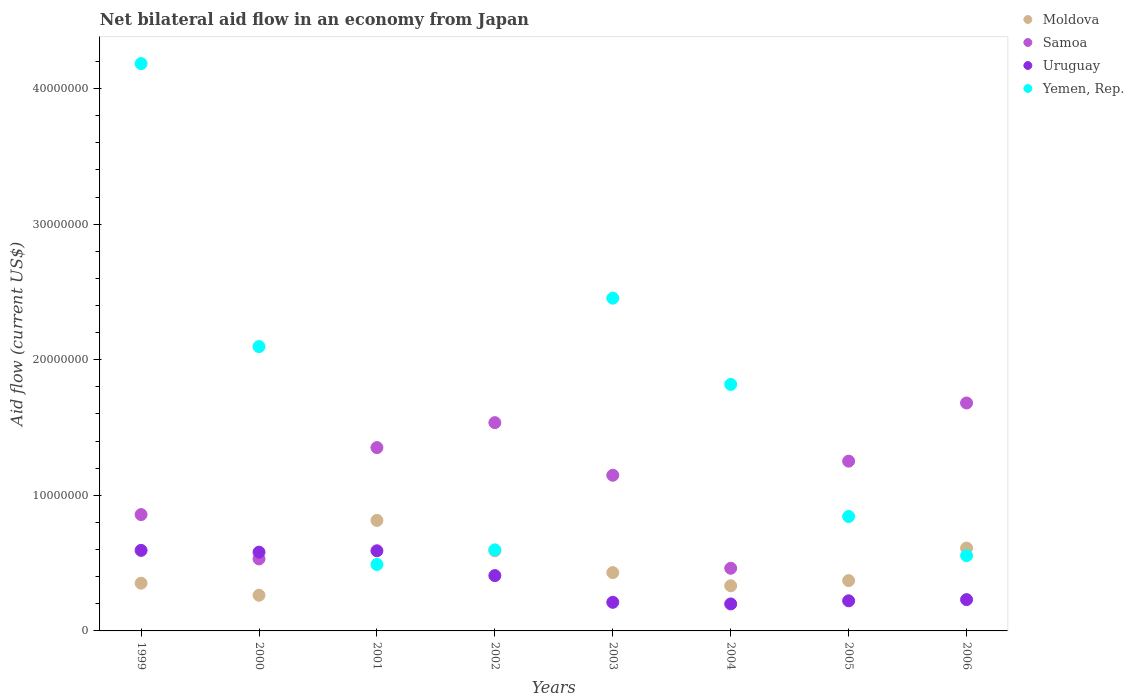What is the net bilateral aid flow in Moldova in 2006?
Your answer should be compact. 6.11e+06. Across all years, what is the maximum net bilateral aid flow in Moldova?
Provide a short and direct response. 8.15e+06. Across all years, what is the minimum net bilateral aid flow in Uruguay?
Provide a succinct answer. 1.99e+06. In which year was the net bilateral aid flow in Yemen, Rep. minimum?
Your answer should be very brief. 2001. What is the total net bilateral aid flow in Uruguay in the graph?
Give a very brief answer. 3.04e+07. What is the difference between the net bilateral aid flow in Samoa in 2001 and that in 2003?
Your answer should be very brief. 2.04e+06. What is the difference between the net bilateral aid flow in Uruguay in 2000 and the net bilateral aid flow in Yemen, Rep. in 2001?
Offer a terse response. 9.10e+05. What is the average net bilateral aid flow in Uruguay per year?
Make the answer very short. 3.80e+06. In the year 1999, what is the difference between the net bilateral aid flow in Moldova and net bilateral aid flow in Yemen, Rep.?
Your response must be concise. -3.83e+07. In how many years, is the net bilateral aid flow in Yemen, Rep. greater than 20000000 US$?
Provide a succinct answer. 3. What is the ratio of the net bilateral aid flow in Yemen, Rep. in 2000 to that in 2004?
Provide a succinct answer. 1.15. Is the net bilateral aid flow in Yemen, Rep. in 2005 less than that in 2006?
Ensure brevity in your answer.  No. What is the difference between the highest and the lowest net bilateral aid flow in Moldova?
Ensure brevity in your answer.  5.52e+06. Is the sum of the net bilateral aid flow in Samoa in 1999 and 2000 greater than the maximum net bilateral aid flow in Yemen, Rep. across all years?
Your answer should be compact. No. Is the net bilateral aid flow in Samoa strictly less than the net bilateral aid flow in Moldova over the years?
Give a very brief answer. No. How many dotlines are there?
Your response must be concise. 4. How many years are there in the graph?
Your response must be concise. 8. Are the values on the major ticks of Y-axis written in scientific E-notation?
Give a very brief answer. No. Does the graph contain any zero values?
Your response must be concise. No. Does the graph contain grids?
Provide a succinct answer. No. Where does the legend appear in the graph?
Offer a very short reply. Top right. How many legend labels are there?
Your response must be concise. 4. What is the title of the graph?
Provide a succinct answer. Net bilateral aid flow in an economy from Japan. What is the Aid flow (current US$) in Moldova in 1999?
Your response must be concise. 3.52e+06. What is the Aid flow (current US$) in Samoa in 1999?
Give a very brief answer. 8.58e+06. What is the Aid flow (current US$) in Uruguay in 1999?
Your answer should be compact. 5.94e+06. What is the Aid flow (current US$) in Yemen, Rep. in 1999?
Offer a very short reply. 4.18e+07. What is the Aid flow (current US$) of Moldova in 2000?
Make the answer very short. 2.63e+06. What is the Aid flow (current US$) of Samoa in 2000?
Your response must be concise. 5.31e+06. What is the Aid flow (current US$) in Uruguay in 2000?
Your answer should be compact. 5.81e+06. What is the Aid flow (current US$) of Yemen, Rep. in 2000?
Your answer should be very brief. 2.10e+07. What is the Aid flow (current US$) of Moldova in 2001?
Your answer should be very brief. 8.15e+06. What is the Aid flow (current US$) of Samoa in 2001?
Your answer should be very brief. 1.35e+07. What is the Aid flow (current US$) in Uruguay in 2001?
Your answer should be compact. 5.91e+06. What is the Aid flow (current US$) in Yemen, Rep. in 2001?
Provide a short and direct response. 4.90e+06. What is the Aid flow (current US$) in Moldova in 2002?
Make the answer very short. 5.91e+06. What is the Aid flow (current US$) in Samoa in 2002?
Make the answer very short. 1.54e+07. What is the Aid flow (current US$) of Uruguay in 2002?
Your answer should be compact. 4.08e+06. What is the Aid flow (current US$) of Yemen, Rep. in 2002?
Your answer should be very brief. 5.98e+06. What is the Aid flow (current US$) in Moldova in 2003?
Your answer should be compact. 4.30e+06. What is the Aid flow (current US$) of Samoa in 2003?
Your response must be concise. 1.15e+07. What is the Aid flow (current US$) in Uruguay in 2003?
Your answer should be compact. 2.11e+06. What is the Aid flow (current US$) of Yemen, Rep. in 2003?
Your answer should be very brief. 2.45e+07. What is the Aid flow (current US$) of Moldova in 2004?
Your answer should be very brief. 3.33e+06. What is the Aid flow (current US$) of Samoa in 2004?
Your answer should be compact. 4.62e+06. What is the Aid flow (current US$) in Uruguay in 2004?
Your answer should be very brief. 1.99e+06. What is the Aid flow (current US$) of Yemen, Rep. in 2004?
Your response must be concise. 1.82e+07. What is the Aid flow (current US$) in Moldova in 2005?
Keep it short and to the point. 3.71e+06. What is the Aid flow (current US$) of Samoa in 2005?
Provide a succinct answer. 1.25e+07. What is the Aid flow (current US$) of Uruguay in 2005?
Ensure brevity in your answer.  2.22e+06. What is the Aid flow (current US$) of Yemen, Rep. in 2005?
Give a very brief answer. 8.44e+06. What is the Aid flow (current US$) of Moldova in 2006?
Offer a terse response. 6.11e+06. What is the Aid flow (current US$) of Samoa in 2006?
Provide a short and direct response. 1.68e+07. What is the Aid flow (current US$) of Uruguay in 2006?
Ensure brevity in your answer.  2.31e+06. What is the Aid flow (current US$) of Yemen, Rep. in 2006?
Offer a very short reply. 5.55e+06. Across all years, what is the maximum Aid flow (current US$) in Moldova?
Your answer should be very brief. 8.15e+06. Across all years, what is the maximum Aid flow (current US$) in Samoa?
Ensure brevity in your answer.  1.68e+07. Across all years, what is the maximum Aid flow (current US$) of Uruguay?
Offer a very short reply. 5.94e+06. Across all years, what is the maximum Aid flow (current US$) in Yemen, Rep.?
Ensure brevity in your answer.  4.18e+07. Across all years, what is the minimum Aid flow (current US$) in Moldova?
Provide a succinct answer. 2.63e+06. Across all years, what is the minimum Aid flow (current US$) in Samoa?
Provide a succinct answer. 4.62e+06. Across all years, what is the minimum Aid flow (current US$) of Uruguay?
Your answer should be very brief. 1.99e+06. Across all years, what is the minimum Aid flow (current US$) of Yemen, Rep.?
Provide a succinct answer. 4.90e+06. What is the total Aid flow (current US$) in Moldova in the graph?
Your response must be concise. 3.77e+07. What is the total Aid flow (current US$) of Samoa in the graph?
Give a very brief answer. 8.82e+07. What is the total Aid flow (current US$) of Uruguay in the graph?
Your answer should be very brief. 3.04e+07. What is the total Aid flow (current US$) of Yemen, Rep. in the graph?
Offer a terse response. 1.30e+08. What is the difference between the Aid flow (current US$) of Moldova in 1999 and that in 2000?
Your response must be concise. 8.90e+05. What is the difference between the Aid flow (current US$) in Samoa in 1999 and that in 2000?
Your answer should be very brief. 3.27e+06. What is the difference between the Aid flow (current US$) of Yemen, Rep. in 1999 and that in 2000?
Give a very brief answer. 2.09e+07. What is the difference between the Aid flow (current US$) in Moldova in 1999 and that in 2001?
Make the answer very short. -4.63e+06. What is the difference between the Aid flow (current US$) of Samoa in 1999 and that in 2001?
Your response must be concise. -4.94e+06. What is the difference between the Aid flow (current US$) in Yemen, Rep. in 1999 and that in 2001?
Provide a short and direct response. 3.69e+07. What is the difference between the Aid flow (current US$) in Moldova in 1999 and that in 2002?
Provide a succinct answer. -2.39e+06. What is the difference between the Aid flow (current US$) in Samoa in 1999 and that in 2002?
Keep it short and to the point. -6.78e+06. What is the difference between the Aid flow (current US$) of Uruguay in 1999 and that in 2002?
Ensure brevity in your answer.  1.86e+06. What is the difference between the Aid flow (current US$) in Yemen, Rep. in 1999 and that in 2002?
Your answer should be compact. 3.59e+07. What is the difference between the Aid flow (current US$) in Moldova in 1999 and that in 2003?
Make the answer very short. -7.80e+05. What is the difference between the Aid flow (current US$) in Samoa in 1999 and that in 2003?
Your response must be concise. -2.90e+06. What is the difference between the Aid flow (current US$) of Uruguay in 1999 and that in 2003?
Ensure brevity in your answer.  3.83e+06. What is the difference between the Aid flow (current US$) of Yemen, Rep. in 1999 and that in 2003?
Your response must be concise. 1.73e+07. What is the difference between the Aid flow (current US$) in Samoa in 1999 and that in 2004?
Keep it short and to the point. 3.96e+06. What is the difference between the Aid flow (current US$) in Uruguay in 1999 and that in 2004?
Your response must be concise. 3.95e+06. What is the difference between the Aid flow (current US$) of Yemen, Rep. in 1999 and that in 2004?
Provide a short and direct response. 2.37e+07. What is the difference between the Aid flow (current US$) in Moldova in 1999 and that in 2005?
Your answer should be compact. -1.90e+05. What is the difference between the Aid flow (current US$) of Samoa in 1999 and that in 2005?
Give a very brief answer. -3.94e+06. What is the difference between the Aid flow (current US$) of Uruguay in 1999 and that in 2005?
Your answer should be very brief. 3.72e+06. What is the difference between the Aid flow (current US$) in Yemen, Rep. in 1999 and that in 2005?
Ensure brevity in your answer.  3.34e+07. What is the difference between the Aid flow (current US$) in Moldova in 1999 and that in 2006?
Offer a terse response. -2.59e+06. What is the difference between the Aid flow (current US$) of Samoa in 1999 and that in 2006?
Offer a very short reply. -8.23e+06. What is the difference between the Aid flow (current US$) of Uruguay in 1999 and that in 2006?
Your response must be concise. 3.63e+06. What is the difference between the Aid flow (current US$) of Yemen, Rep. in 1999 and that in 2006?
Provide a succinct answer. 3.63e+07. What is the difference between the Aid flow (current US$) in Moldova in 2000 and that in 2001?
Your answer should be very brief. -5.52e+06. What is the difference between the Aid flow (current US$) in Samoa in 2000 and that in 2001?
Offer a very short reply. -8.21e+06. What is the difference between the Aid flow (current US$) of Yemen, Rep. in 2000 and that in 2001?
Provide a succinct answer. 1.61e+07. What is the difference between the Aid flow (current US$) in Moldova in 2000 and that in 2002?
Provide a succinct answer. -3.28e+06. What is the difference between the Aid flow (current US$) in Samoa in 2000 and that in 2002?
Your answer should be compact. -1.00e+07. What is the difference between the Aid flow (current US$) of Uruguay in 2000 and that in 2002?
Provide a succinct answer. 1.73e+06. What is the difference between the Aid flow (current US$) in Yemen, Rep. in 2000 and that in 2002?
Offer a terse response. 1.50e+07. What is the difference between the Aid flow (current US$) of Moldova in 2000 and that in 2003?
Provide a short and direct response. -1.67e+06. What is the difference between the Aid flow (current US$) in Samoa in 2000 and that in 2003?
Make the answer very short. -6.17e+06. What is the difference between the Aid flow (current US$) of Uruguay in 2000 and that in 2003?
Make the answer very short. 3.70e+06. What is the difference between the Aid flow (current US$) in Yemen, Rep. in 2000 and that in 2003?
Your answer should be compact. -3.57e+06. What is the difference between the Aid flow (current US$) of Moldova in 2000 and that in 2004?
Provide a succinct answer. -7.00e+05. What is the difference between the Aid flow (current US$) of Samoa in 2000 and that in 2004?
Ensure brevity in your answer.  6.90e+05. What is the difference between the Aid flow (current US$) in Uruguay in 2000 and that in 2004?
Ensure brevity in your answer.  3.82e+06. What is the difference between the Aid flow (current US$) in Yemen, Rep. in 2000 and that in 2004?
Give a very brief answer. 2.79e+06. What is the difference between the Aid flow (current US$) of Moldova in 2000 and that in 2005?
Keep it short and to the point. -1.08e+06. What is the difference between the Aid flow (current US$) in Samoa in 2000 and that in 2005?
Your response must be concise. -7.21e+06. What is the difference between the Aid flow (current US$) in Uruguay in 2000 and that in 2005?
Make the answer very short. 3.59e+06. What is the difference between the Aid flow (current US$) in Yemen, Rep. in 2000 and that in 2005?
Give a very brief answer. 1.25e+07. What is the difference between the Aid flow (current US$) in Moldova in 2000 and that in 2006?
Provide a short and direct response. -3.48e+06. What is the difference between the Aid flow (current US$) in Samoa in 2000 and that in 2006?
Provide a succinct answer. -1.15e+07. What is the difference between the Aid flow (current US$) of Uruguay in 2000 and that in 2006?
Offer a very short reply. 3.50e+06. What is the difference between the Aid flow (current US$) in Yemen, Rep. in 2000 and that in 2006?
Make the answer very short. 1.54e+07. What is the difference between the Aid flow (current US$) of Moldova in 2001 and that in 2002?
Provide a short and direct response. 2.24e+06. What is the difference between the Aid flow (current US$) of Samoa in 2001 and that in 2002?
Offer a very short reply. -1.84e+06. What is the difference between the Aid flow (current US$) in Uruguay in 2001 and that in 2002?
Give a very brief answer. 1.83e+06. What is the difference between the Aid flow (current US$) of Yemen, Rep. in 2001 and that in 2002?
Give a very brief answer. -1.08e+06. What is the difference between the Aid flow (current US$) of Moldova in 2001 and that in 2003?
Provide a succinct answer. 3.85e+06. What is the difference between the Aid flow (current US$) in Samoa in 2001 and that in 2003?
Ensure brevity in your answer.  2.04e+06. What is the difference between the Aid flow (current US$) in Uruguay in 2001 and that in 2003?
Provide a short and direct response. 3.80e+06. What is the difference between the Aid flow (current US$) in Yemen, Rep. in 2001 and that in 2003?
Make the answer very short. -1.96e+07. What is the difference between the Aid flow (current US$) of Moldova in 2001 and that in 2004?
Your response must be concise. 4.82e+06. What is the difference between the Aid flow (current US$) of Samoa in 2001 and that in 2004?
Give a very brief answer. 8.90e+06. What is the difference between the Aid flow (current US$) in Uruguay in 2001 and that in 2004?
Ensure brevity in your answer.  3.92e+06. What is the difference between the Aid flow (current US$) in Yemen, Rep. in 2001 and that in 2004?
Keep it short and to the point. -1.33e+07. What is the difference between the Aid flow (current US$) in Moldova in 2001 and that in 2005?
Your answer should be compact. 4.44e+06. What is the difference between the Aid flow (current US$) in Uruguay in 2001 and that in 2005?
Keep it short and to the point. 3.69e+06. What is the difference between the Aid flow (current US$) of Yemen, Rep. in 2001 and that in 2005?
Ensure brevity in your answer.  -3.54e+06. What is the difference between the Aid flow (current US$) of Moldova in 2001 and that in 2006?
Make the answer very short. 2.04e+06. What is the difference between the Aid flow (current US$) of Samoa in 2001 and that in 2006?
Keep it short and to the point. -3.29e+06. What is the difference between the Aid flow (current US$) of Uruguay in 2001 and that in 2006?
Offer a terse response. 3.60e+06. What is the difference between the Aid flow (current US$) in Yemen, Rep. in 2001 and that in 2006?
Give a very brief answer. -6.50e+05. What is the difference between the Aid flow (current US$) of Moldova in 2002 and that in 2003?
Offer a terse response. 1.61e+06. What is the difference between the Aid flow (current US$) in Samoa in 2002 and that in 2003?
Give a very brief answer. 3.88e+06. What is the difference between the Aid flow (current US$) in Uruguay in 2002 and that in 2003?
Ensure brevity in your answer.  1.97e+06. What is the difference between the Aid flow (current US$) of Yemen, Rep. in 2002 and that in 2003?
Ensure brevity in your answer.  -1.86e+07. What is the difference between the Aid flow (current US$) of Moldova in 2002 and that in 2004?
Give a very brief answer. 2.58e+06. What is the difference between the Aid flow (current US$) in Samoa in 2002 and that in 2004?
Your answer should be very brief. 1.07e+07. What is the difference between the Aid flow (current US$) of Uruguay in 2002 and that in 2004?
Provide a succinct answer. 2.09e+06. What is the difference between the Aid flow (current US$) in Yemen, Rep. in 2002 and that in 2004?
Ensure brevity in your answer.  -1.22e+07. What is the difference between the Aid flow (current US$) of Moldova in 2002 and that in 2005?
Provide a succinct answer. 2.20e+06. What is the difference between the Aid flow (current US$) of Samoa in 2002 and that in 2005?
Provide a short and direct response. 2.84e+06. What is the difference between the Aid flow (current US$) in Uruguay in 2002 and that in 2005?
Your answer should be very brief. 1.86e+06. What is the difference between the Aid flow (current US$) of Yemen, Rep. in 2002 and that in 2005?
Give a very brief answer. -2.46e+06. What is the difference between the Aid flow (current US$) of Moldova in 2002 and that in 2006?
Provide a short and direct response. -2.00e+05. What is the difference between the Aid flow (current US$) of Samoa in 2002 and that in 2006?
Your answer should be compact. -1.45e+06. What is the difference between the Aid flow (current US$) in Uruguay in 2002 and that in 2006?
Provide a succinct answer. 1.77e+06. What is the difference between the Aid flow (current US$) in Moldova in 2003 and that in 2004?
Ensure brevity in your answer.  9.70e+05. What is the difference between the Aid flow (current US$) of Samoa in 2003 and that in 2004?
Offer a very short reply. 6.86e+06. What is the difference between the Aid flow (current US$) of Uruguay in 2003 and that in 2004?
Offer a very short reply. 1.20e+05. What is the difference between the Aid flow (current US$) in Yemen, Rep. in 2003 and that in 2004?
Provide a succinct answer. 6.36e+06. What is the difference between the Aid flow (current US$) of Moldova in 2003 and that in 2005?
Ensure brevity in your answer.  5.90e+05. What is the difference between the Aid flow (current US$) in Samoa in 2003 and that in 2005?
Ensure brevity in your answer.  -1.04e+06. What is the difference between the Aid flow (current US$) of Yemen, Rep. in 2003 and that in 2005?
Your answer should be compact. 1.61e+07. What is the difference between the Aid flow (current US$) in Moldova in 2003 and that in 2006?
Keep it short and to the point. -1.81e+06. What is the difference between the Aid flow (current US$) of Samoa in 2003 and that in 2006?
Give a very brief answer. -5.33e+06. What is the difference between the Aid flow (current US$) in Uruguay in 2003 and that in 2006?
Your response must be concise. -2.00e+05. What is the difference between the Aid flow (current US$) in Yemen, Rep. in 2003 and that in 2006?
Offer a terse response. 1.90e+07. What is the difference between the Aid flow (current US$) of Moldova in 2004 and that in 2005?
Your answer should be very brief. -3.80e+05. What is the difference between the Aid flow (current US$) of Samoa in 2004 and that in 2005?
Provide a short and direct response. -7.90e+06. What is the difference between the Aid flow (current US$) of Yemen, Rep. in 2004 and that in 2005?
Make the answer very short. 9.74e+06. What is the difference between the Aid flow (current US$) of Moldova in 2004 and that in 2006?
Provide a short and direct response. -2.78e+06. What is the difference between the Aid flow (current US$) in Samoa in 2004 and that in 2006?
Your answer should be compact. -1.22e+07. What is the difference between the Aid flow (current US$) in Uruguay in 2004 and that in 2006?
Your answer should be compact. -3.20e+05. What is the difference between the Aid flow (current US$) in Yemen, Rep. in 2004 and that in 2006?
Give a very brief answer. 1.26e+07. What is the difference between the Aid flow (current US$) in Moldova in 2005 and that in 2006?
Make the answer very short. -2.40e+06. What is the difference between the Aid flow (current US$) in Samoa in 2005 and that in 2006?
Provide a short and direct response. -4.29e+06. What is the difference between the Aid flow (current US$) of Yemen, Rep. in 2005 and that in 2006?
Offer a very short reply. 2.89e+06. What is the difference between the Aid flow (current US$) in Moldova in 1999 and the Aid flow (current US$) in Samoa in 2000?
Give a very brief answer. -1.79e+06. What is the difference between the Aid flow (current US$) of Moldova in 1999 and the Aid flow (current US$) of Uruguay in 2000?
Provide a short and direct response. -2.29e+06. What is the difference between the Aid flow (current US$) of Moldova in 1999 and the Aid flow (current US$) of Yemen, Rep. in 2000?
Your response must be concise. -1.74e+07. What is the difference between the Aid flow (current US$) of Samoa in 1999 and the Aid flow (current US$) of Uruguay in 2000?
Offer a very short reply. 2.77e+06. What is the difference between the Aid flow (current US$) in Samoa in 1999 and the Aid flow (current US$) in Yemen, Rep. in 2000?
Offer a terse response. -1.24e+07. What is the difference between the Aid flow (current US$) of Uruguay in 1999 and the Aid flow (current US$) of Yemen, Rep. in 2000?
Keep it short and to the point. -1.50e+07. What is the difference between the Aid flow (current US$) in Moldova in 1999 and the Aid flow (current US$) in Samoa in 2001?
Offer a very short reply. -1.00e+07. What is the difference between the Aid flow (current US$) in Moldova in 1999 and the Aid flow (current US$) in Uruguay in 2001?
Make the answer very short. -2.39e+06. What is the difference between the Aid flow (current US$) in Moldova in 1999 and the Aid flow (current US$) in Yemen, Rep. in 2001?
Ensure brevity in your answer.  -1.38e+06. What is the difference between the Aid flow (current US$) of Samoa in 1999 and the Aid flow (current US$) of Uruguay in 2001?
Offer a very short reply. 2.67e+06. What is the difference between the Aid flow (current US$) of Samoa in 1999 and the Aid flow (current US$) of Yemen, Rep. in 2001?
Your answer should be compact. 3.68e+06. What is the difference between the Aid flow (current US$) of Uruguay in 1999 and the Aid flow (current US$) of Yemen, Rep. in 2001?
Provide a short and direct response. 1.04e+06. What is the difference between the Aid flow (current US$) of Moldova in 1999 and the Aid flow (current US$) of Samoa in 2002?
Your answer should be very brief. -1.18e+07. What is the difference between the Aid flow (current US$) in Moldova in 1999 and the Aid flow (current US$) in Uruguay in 2002?
Offer a terse response. -5.60e+05. What is the difference between the Aid flow (current US$) in Moldova in 1999 and the Aid flow (current US$) in Yemen, Rep. in 2002?
Give a very brief answer. -2.46e+06. What is the difference between the Aid flow (current US$) of Samoa in 1999 and the Aid flow (current US$) of Uruguay in 2002?
Offer a terse response. 4.50e+06. What is the difference between the Aid flow (current US$) of Samoa in 1999 and the Aid flow (current US$) of Yemen, Rep. in 2002?
Make the answer very short. 2.60e+06. What is the difference between the Aid flow (current US$) of Uruguay in 1999 and the Aid flow (current US$) of Yemen, Rep. in 2002?
Your answer should be compact. -4.00e+04. What is the difference between the Aid flow (current US$) in Moldova in 1999 and the Aid flow (current US$) in Samoa in 2003?
Make the answer very short. -7.96e+06. What is the difference between the Aid flow (current US$) in Moldova in 1999 and the Aid flow (current US$) in Uruguay in 2003?
Offer a very short reply. 1.41e+06. What is the difference between the Aid flow (current US$) in Moldova in 1999 and the Aid flow (current US$) in Yemen, Rep. in 2003?
Keep it short and to the point. -2.10e+07. What is the difference between the Aid flow (current US$) of Samoa in 1999 and the Aid flow (current US$) of Uruguay in 2003?
Make the answer very short. 6.47e+06. What is the difference between the Aid flow (current US$) of Samoa in 1999 and the Aid flow (current US$) of Yemen, Rep. in 2003?
Keep it short and to the point. -1.60e+07. What is the difference between the Aid flow (current US$) in Uruguay in 1999 and the Aid flow (current US$) in Yemen, Rep. in 2003?
Give a very brief answer. -1.86e+07. What is the difference between the Aid flow (current US$) in Moldova in 1999 and the Aid flow (current US$) in Samoa in 2004?
Keep it short and to the point. -1.10e+06. What is the difference between the Aid flow (current US$) in Moldova in 1999 and the Aid flow (current US$) in Uruguay in 2004?
Provide a short and direct response. 1.53e+06. What is the difference between the Aid flow (current US$) in Moldova in 1999 and the Aid flow (current US$) in Yemen, Rep. in 2004?
Your answer should be very brief. -1.47e+07. What is the difference between the Aid flow (current US$) of Samoa in 1999 and the Aid flow (current US$) of Uruguay in 2004?
Keep it short and to the point. 6.59e+06. What is the difference between the Aid flow (current US$) of Samoa in 1999 and the Aid flow (current US$) of Yemen, Rep. in 2004?
Offer a terse response. -9.60e+06. What is the difference between the Aid flow (current US$) of Uruguay in 1999 and the Aid flow (current US$) of Yemen, Rep. in 2004?
Make the answer very short. -1.22e+07. What is the difference between the Aid flow (current US$) of Moldova in 1999 and the Aid flow (current US$) of Samoa in 2005?
Your answer should be very brief. -9.00e+06. What is the difference between the Aid flow (current US$) of Moldova in 1999 and the Aid flow (current US$) of Uruguay in 2005?
Make the answer very short. 1.30e+06. What is the difference between the Aid flow (current US$) in Moldova in 1999 and the Aid flow (current US$) in Yemen, Rep. in 2005?
Offer a terse response. -4.92e+06. What is the difference between the Aid flow (current US$) of Samoa in 1999 and the Aid flow (current US$) of Uruguay in 2005?
Ensure brevity in your answer.  6.36e+06. What is the difference between the Aid flow (current US$) in Uruguay in 1999 and the Aid flow (current US$) in Yemen, Rep. in 2005?
Offer a very short reply. -2.50e+06. What is the difference between the Aid flow (current US$) of Moldova in 1999 and the Aid flow (current US$) of Samoa in 2006?
Make the answer very short. -1.33e+07. What is the difference between the Aid flow (current US$) in Moldova in 1999 and the Aid flow (current US$) in Uruguay in 2006?
Your answer should be compact. 1.21e+06. What is the difference between the Aid flow (current US$) in Moldova in 1999 and the Aid flow (current US$) in Yemen, Rep. in 2006?
Offer a terse response. -2.03e+06. What is the difference between the Aid flow (current US$) in Samoa in 1999 and the Aid flow (current US$) in Uruguay in 2006?
Give a very brief answer. 6.27e+06. What is the difference between the Aid flow (current US$) of Samoa in 1999 and the Aid flow (current US$) of Yemen, Rep. in 2006?
Make the answer very short. 3.03e+06. What is the difference between the Aid flow (current US$) in Uruguay in 1999 and the Aid flow (current US$) in Yemen, Rep. in 2006?
Keep it short and to the point. 3.90e+05. What is the difference between the Aid flow (current US$) in Moldova in 2000 and the Aid flow (current US$) in Samoa in 2001?
Your response must be concise. -1.09e+07. What is the difference between the Aid flow (current US$) in Moldova in 2000 and the Aid flow (current US$) in Uruguay in 2001?
Offer a terse response. -3.28e+06. What is the difference between the Aid flow (current US$) of Moldova in 2000 and the Aid flow (current US$) of Yemen, Rep. in 2001?
Give a very brief answer. -2.27e+06. What is the difference between the Aid flow (current US$) in Samoa in 2000 and the Aid flow (current US$) in Uruguay in 2001?
Your answer should be very brief. -6.00e+05. What is the difference between the Aid flow (current US$) in Uruguay in 2000 and the Aid flow (current US$) in Yemen, Rep. in 2001?
Your answer should be very brief. 9.10e+05. What is the difference between the Aid flow (current US$) in Moldova in 2000 and the Aid flow (current US$) in Samoa in 2002?
Ensure brevity in your answer.  -1.27e+07. What is the difference between the Aid flow (current US$) of Moldova in 2000 and the Aid flow (current US$) of Uruguay in 2002?
Your response must be concise. -1.45e+06. What is the difference between the Aid flow (current US$) of Moldova in 2000 and the Aid flow (current US$) of Yemen, Rep. in 2002?
Offer a very short reply. -3.35e+06. What is the difference between the Aid flow (current US$) of Samoa in 2000 and the Aid flow (current US$) of Uruguay in 2002?
Provide a succinct answer. 1.23e+06. What is the difference between the Aid flow (current US$) of Samoa in 2000 and the Aid flow (current US$) of Yemen, Rep. in 2002?
Your answer should be compact. -6.70e+05. What is the difference between the Aid flow (current US$) of Moldova in 2000 and the Aid flow (current US$) of Samoa in 2003?
Give a very brief answer. -8.85e+06. What is the difference between the Aid flow (current US$) of Moldova in 2000 and the Aid flow (current US$) of Uruguay in 2003?
Offer a very short reply. 5.20e+05. What is the difference between the Aid flow (current US$) in Moldova in 2000 and the Aid flow (current US$) in Yemen, Rep. in 2003?
Make the answer very short. -2.19e+07. What is the difference between the Aid flow (current US$) of Samoa in 2000 and the Aid flow (current US$) of Uruguay in 2003?
Give a very brief answer. 3.20e+06. What is the difference between the Aid flow (current US$) of Samoa in 2000 and the Aid flow (current US$) of Yemen, Rep. in 2003?
Offer a very short reply. -1.92e+07. What is the difference between the Aid flow (current US$) in Uruguay in 2000 and the Aid flow (current US$) in Yemen, Rep. in 2003?
Give a very brief answer. -1.87e+07. What is the difference between the Aid flow (current US$) in Moldova in 2000 and the Aid flow (current US$) in Samoa in 2004?
Provide a succinct answer. -1.99e+06. What is the difference between the Aid flow (current US$) of Moldova in 2000 and the Aid flow (current US$) of Uruguay in 2004?
Offer a very short reply. 6.40e+05. What is the difference between the Aid flow (current US$) in Moldova in 2000 and the Aid flow (current US$) in Yemen, Rep. in 2004?
Keep it short and to the point. -1.56e+07. What is the difference between the Aid flow (current US$) in Samoa in 2000 and the Aid flow (current US$) in Uruguay in 2004?
Provide a short and direct response. 3.32e+06. What is the difference between the Aid flow (current US$) in Samoa in 2000 and the Aid flow (current US$) in Yemen, Rep. in 2004?
Give a very brief answer. -1.29e+07. What is the difference between the Aid flow (current US$) of Uruguay in 2000 and the Aid flow (current US$) of Yemen, Rep. in 2004?
Give a very brief answer. -1.24e+07. What is the difference between the Aid flow (current US$) of Moldova in 2000 and the Aid flow (current US$) of Samoa in 2005?
Your answer should be compact. -9.89e+06. What is the difference between the Aid flow (current US$) of Moldova in 2000 and the Aid flow (current US$) of Yemen, Rep. in 2005?
Your answer should be very brief. -5.81e+06. What is the difference between the Aid flow (current US$) in Samoa in 2000 and the Aid flow (current US$) in Uruguay in 2005?
Offer a terse response. 3.09e+06. What is the difference between the Aid flow (current US$) of Samoa in 2000 and the Aid flow (current US$) of Yemen, Rep. in 2005?
Give a very brief answer. -3.13e+06. What is the difference between the Aid flow (current US$) of Uruguay in 2000 and the Aid flow (current US$) of Yemen, Rep. in 2005?
Provide a short and direct response. -2.63e+06. What is the difference between the Aid flow (current US$) of Moldova in 2000 and the Aid flow (current US$) of Samoa in 2006?
Ensure brevity in your answer.  -1.42e+07. What is the difference between the Aid flow (current US$) of Moldova in 2000 and the Aid flow (current US$) of Uruguay in 2006?
Offer a terse response. 3.20e+05. What is the difference between the Aid flow (current US$) of Moldova in 2000 and the Aid flow (current US$) of Yemen, Rep. in 2006?
Give a very brief answer. -2.92e+06. What is the difference between the Aid flow (current US$) in Moldova in 2001 and the Aid flow (current US$) in Samoa in 2002?
Give a very brief answer. -7.21e+06. What is the difference between the Aid flow (current US$) in Moldova in 2001 and the Aid flow (current US$) in Uruguay in 2002?
Your response must be concise. 4.07e+06. What is the difference between the Aid flow (current US$) of Moldova in 2001 and the Aid flow (current US$) of Yemen, Rep. in 2002?
Ensure brevity in your answer.  2.17e+06. What is the difference between the Aid flow (current US$) in Samoa in 2001 and the Aid flow (current US$) in Uruguay in 2002?
Your answer should be compact. 9.44e+06. What is the difference between the Aid flow (current US$) in Samoa in 2001 and the Aid flow (current US$) in Yemen, Rep. in 2002?
Your response must be concise. 7.54e+06. What is the difference between the Aid flow (current US$) of Uruguay in 2001 and the Aid flow (current US$) of Yemen, Rep. in 2002?
Provide a succinct answer. -7.00e+04. What is the difference between the Aid flow (current US$) of Moldova in 2001 and the Aid flow (current US$) of Samoa in 2003?
Your response must be concise. -3.33e+06. What is the difference between the Aid flow (current US$) of Moldova in 2001 and the Aid flow (current US$) of Uruguay in 2003?
Your answer should be very brief. 6.04e+06. What is the difference between the Aid flow (current US$) of Moldova in 2001 and the Aid flow (current US$) of Yemen, Rep. in 2003?
Ensure brevity in your answer.  -1.64e+07. What is the difference between the Aid flow (current US$) of Samoa in 2001 and the Aid flow (current US$) of Uruguay in 2003?
Keep it short and to the point. 1.14e+07. What is the difference between the Aid flow (current US$) in Samoa in 2001 and the Aid flow (current US$) in Yemen, Rep. in 2003?
Offer a terse response. -1.10e+07. What is the difference between the Aid flow (current US$) in Uruguay in 2001 and the Aid flow (current US$) in Yemen, Rep. in 2003?
Provide a short and direct response. -1.86e+07. What is the difference between the Aid flow (current US$) of Moldova in 2001 and the Aid flow (current US$) of Samoa in 2004?
Give a very brief answer. 3.53e+06. What is the difference between the Aid flow (current US$) in Moldova in 2001 and the Aid flow (current US$) in Uruguay in 2004?
Your answer should be very brief. 6.16e+06. What is the difference between the Aid flow (current US$) in Moldova in 2001 and the Aid flow (current US$) in Yemen, Rep. in 2004?
Give a very brief answer. -1.00e+07. What is the difference between the Aid flow (current US$) in Samoa in 2001 and the Aid flow (current US$) in Uruguay in 2004?
Provide a succinct answer. 1.15e+07. What is the difference between the Aid flow (current US$) in Samoa in 2001 and the Aid flow (current US$) in Yemen, Rep. in 2004?
Offer a terse response. -4.66e+06. What is the difference between the Aid flow (current US$) of Uruguay in 2001 and the Aid flow (current US$) of Yemen, Rep. in 2004?
Offer a very short reply. -1.23e+07. What is the difference between the Aid flow (current US$) of Moldova in 2001 and the Aid flow (current US$) of Samoa in 2005?
Your response must be concise. -4.37e+06. What is the difference between the Aid flow (current US$) in Moldova in 2001 and the Aid flow (current US$) in Uruguay in 2005?
Your answer should be compact. 5.93e+06. What is the difference between the Aid flow (current US$) in Moldova in 2001 and the Aid flow (current US$) in Yemen, Rep. in 2005?
Make the answer very short. -2.90e+05. What is the difference between the Aid flow (current US$) of Samoa in 2001 and the Aid flow (current US$) of Uruguay in 2005?
Make the answer very short. 1.13e+07. What is the difference between the Aid flow (current US$) in Samoa in 2001 and the Aid flow (current US$) in Yemen, Rep. in 2005?
Provide a succinct answer. 5.08e+06. What is the difference between the Aid flow (current US$) in Uruguay in 2001 and the Aid flow (current US$) in Yemen, Rep. in 2005?
Offer a terse response. -2.53e+06. What is the difference between the Aid flow (current US$) of Moldova in 2001 and the Aid flow (current US$) of Samoa in 2006?
Give a very brief answer. -8.66e+06. What is the difference between the Aid flow (current US$) of Moldova in 2001 and the Aid flow (current US$) of Uruguay in 2006?
Offer a terse response. 5.84e+06. What is the difference between the Aid flow (current US$) in Moldova in 2001 and the Aid flow (current US$) in Yemen, Rep. in 2006?
Keep it short and to the point. 2.60e+06. What is the difference between the Aid flow (current US$) in Samoa in 2001 and the Aid flow (current US$) in Uruguay in 2006?
Offer a terse response. 1.12e+07. What is the difference between the Aid flow (current US$) in Samoa in 2001 and the Aid flow (current US$) in Yemen, Rep. in 2006?
Make the answer very short. 7.97e+06. What is the difference between the Aid flow (current US$) in Uruguay in 2001 and the Aid flow (current US$) in Yemen, Rep. in 2006?
Make the answer very short. 3.60e+05. What is the difference between the Aid flow (current US$) of Moldova in 2002 and the Aid flow (current US$) of Samoa in 2003?
Keep it short and to the point. -5.57e+06. What is the difference between the Aid flow (current US$) of Moldova in 2002 and the Aid flow (current US$) of Uruguay in 2003?
Your answer should be compact. 3.80e+06. What is the difference between the Aid flow (current US$) in Moldova in 2002 and the Aid flow (current US$) in Yemen, Rep. in 2003?
Your answer should be compact. -1.86e+07. What is the difference between the Aid flow (current US$) of Samoa in 2002 and the Aid flow (current US$) of Uruguay in 2003?
Provide a succinct answer. 1.32e+07. What is the difference between the Aid flow (current US$) of Samoa in 2002 and the Aid flow (current US$) of Yemen, Rep. in 2003?
Your answer should be very brief. -9.18e+06. What is the difference between the Aid flow (current US$) in Uruguay in 2002 and the Aid flow (current US$) in Yemen, Rep. in 2003?
Your response must be concise. -2.05e+07. What is the difference between the Aid flow (current US$) of Moldova in 2002 and the Aid flow (current US$) of Samoa in 2004?
Ensure brevity in your answer.  1.29e+06. What is the difference between the Aid flow (current US$) of Moldova in 2002 and the Aid flow (current US$) of Uruguay in 2004?
Ensure brevity in your answer.  3.92e+06. What is the difference between the Aid flow (current US$) of Moldova in 2002 and the Aid flow (current US$) of Yemen, Rep. in 2004?
Offer a terse response. -1.23e+07. What is the difference between the Aid flow (current US$) in Samoa in 2002 and the Aid flow (current US$) in Uruguay in 2004?
Give a very brief answer. 1.34e+07. What is the difference between the Aid flow (current US$) of Samoa in 2002 and the Aid flow (current US$) of Yemen, Rep. in 2004?
Provide a short and direct response. -2.82e+06. What is the difference between the Aid flow (current US$) of Uruguay in 2002 and the Aid flow (current US$) of Yemen, Rep. in 2004?
Offer a terse response. -1.41e+07. What is the difference between the Aid flow (current US$) of Moldova in 2002 and the Aid flow (current US$) of Samoa in 2005?
Ensure brevity in your answer.  -6.61e+06. What is the difference between the Aid flow (current US$) of Moldova in 2002 and the Aid flow (current US$) of Uruguay in 2005?
Ensure brevity in your answer.  3.69e+06. What is the difference between the Aid flow (current US$) of Moldova in 2002 and the Aid flow (current US$) of Yemen, Rep. in 2005?
Give a very brief answer. -2.53e+06. What is the difference between the Aid flow (current US$) of Samoa in 2002 and the Aid flow (current US$) of Uruguay in 2005?
Offer a very short reply. 1.31e+07. What is the difference between the Aid flow (current US$) in Samoa in 2002 and the Aid flow (current US$) in Yemen, Rep. in 2005?
Make the answer very short. 6.92e+06. What is the difference between the Aid flow (current US$) of Uruguay in 2002 and the Aid flow (current US$) of Yemen, Rep. in 2005?
Your answer should be very brief. -4.36e+06. What is the difference between the Aid flow (current US$) of Moldova in 2002 and the Aid flow (current US$) of Samoa in 2006?
Ensure brevity in your answer.  -1.09e+07. What is the difference between the Aid flow (current US$) of Moldova in 2002 and the Aid flow (current US$) of Uruguay in 2006?
Your response must be concise. 3.60e+06. What is the difference between the Aid flow (current US$) of Samoa in 2002 and the Aid flow (current US$) of Uruguay in 2006?
Give a very brief answer. 1.30e+07. What is the difference between the Aid flow (current US$) of Samoa in 2002 and the Aid flow (current US$) of Yemen, Rep. in 2006?
Offer a very short reply. 9.81e+06. What is the difference between the Aid flow (current US$) in Uruguay in 2002 and the Aid flow (current US$) in Yemen, Rep. in 2006?
Give a very brief answer. -1.47e+06. What is the difference between the Aid flow (current US$) of Moldova in 2003 and the Aid flow (current US$) of Samoa in 2004?
Provide a short and direct response. -3.20e+05. What is the difference between the Aid flow (current US$) in Moldova in 2003 and the Aid flow (current US$) in Uruguay in 2004?
Provide a succinct answer. 2.31e+06. What is the difference between the Aid flow (current US$) in Moldova in 2003 and the Aid flow (current US$) in Yemen, Rep. in 2004?
Give a very brief answer. -1.39e+07. What is the difference between the Aid flow (current US$) in Samoa in 2003 and the Aid flow (current US$) in Uruguay in 2004?
Provide a short and direct response. 9.49e+06. What is the difference between the Aid flow (current US$) in Samoa in 2003 and the Aid flow (current US$) in Yemen, Rep. in 2004?
Offer a terse response. -6.70e+06. What is the difference between the Aid flow (current US$) of Uruguay in 2003 and the Aid flow (current US$) of Yemen, Rep. in 2004?
Your answer should be compact. -1.61e+07. What is the difference between the Aid flow (current US$) of Moldova in 2003 and the Aid flow (current US$) of Samoa in 2005?
Give a very brief answer. -8.22e+06. What is the difference between the Aid flow (current US$) of Moldova in 2003 and the Aid flow (current US$) of Uruguay in 2005?
Offer a very short reply. 2.08e+06. What is the difference between the Aid flow (current US$) in Moldova in 2003 and the Aid flow (current US$) in Yemen, Rep. in 2005?
Offer a terse response. -4.14e+06. What is the difference between the Aid flow (current US$) in Samoa in 2003 and the Aid flow (current US$) in Uruguay in 2005?
Keep it short and to the point. 9.26e+06. What is the difference between the Aid flow (current US$) of Samoa in 2003 and the Aid flow (current US$) of Yemen, Rep. in 2005?
Make the answer very short. 3.04e+06. What is the difference between the Aid flow (current US$) in Uruguay in 2003 and the Aid flow (current US$) in Yemen, Rep. in 2005?
Provide a short and direct response. -6.33e+06. What is the difference between the Aid flow (current US$) in Moldova in 2003 and the Aid flow (current US$) in Samoa in 2006?
Your response must be concise. -1.25e+07. What is the difference between the Aid flow (current US$) of Moldova in 2003 and the Aid flow (current US$) of Uruguay in 2006?
Provide a short and direct response. 1.99e+06. What is the difference between the Aid flow (current US$) of Moldova in 2003 and the Aid flow (current US$) of Yemen, Rep. in 2006?
Your response must be concise. -1.25e+06. What is the difference between the Aid flow (current US$) of Samoa in 2003 and the Aid flow (current US$) of Uruguay in 2006?
Provide a short and direct response. 9.17e+06. What is the difference between the Aid flow (current US$) of Samoa in 2003 and the Aid flow (current US$) of Yemen, Rep. in 2006?
Ensure brevity in your answer.  5.93e+06. What is the difference between the Aid flow (current US$) of Uruguay in 2003 and the Aid flow (current US$) of Yemen, Rep. in 2006?
Offer a terse response. -3.44e+06. What is the difference between the Aid flow (current US$) in Moldova in 2004 and the Aid flow (current US$) in Samoa in 2005?
Your answer should be very brief. -9.19e+06. What is the difference between the Aid flow (current US$) of Moldova in 2004 and the Aid flow (current US$) of Uruguay in 2005?
Keep it short and to the point. 1.11e+06. What is the difference between the Aid flow (current US$) in Moldova in 2004 and the Aid flow (current US$) in Yemen, Rep. in 2005?
Your response must be concise. -5.11e+06. What is the difference between the Aid flow (current US$) in Samoa in 2004 and the Aid flow (current US$) in Uruguay in 2005?
Keep it short and to the point. 2.40e+06. What is the difference between the Aid flow (current US$) of Samoa in 2004 and the Aid flow (current US$) of Yemen, Rep. in 2005?
Offer a terse response. -3.82e+06. What is the difference between the Aid flow (current US$) in Uruguay in 2004 and the Aid flow (current US$) in Yemen, Rep. in 2005?
Give a very brief answer. -6.45e+06. What is the difference between the Aid flow (current US$) in Moldova in 2004 and the Aid flow (current US$) in Samoa in 2006?
Make the answer very short. -1.35e+07. What is the difference between the Aid flow (current US$) of Moldova in 2004 and the Aid flow (current US$) of Uruguay in 2006?
Provide a succinct answer. 1.02e+06. What is the difference between the Aid flow (current US$) in Moldova in 2004 and the Aid flow (current US$) in Yemen, Rep. in 2006?
Offer a terse response. -2.22e+06. What is the difference between the Aid flow (current US$) of Samoa in 2004 and the Aid flow (current US$) of Uruguay in 2006?
Your response must be concise. 2.31e+06. What is the difference between the Aid flow (current US$) of Samoa in 2004 and the Aid flow (current US$) of Yemen, Rep. in 2006?
Give a very brief answer. -9.30e+05. What is the difference between the Aid flow (current US$) of Uruguay in 2004 and the Aid flow (current US$) of Yemen, Rep. in 2006?
Ensure brevity in your answer.  -3.56e+06. What is the difference between the Aid flow (current US$) of Moldova in 2005 and the Aid flow (current US$) of Samoa in 2006?
Your response must be concise. -1.31e+07. What is the difference between the Aid flow (current US$) of Moldova in 2005 and the Aid flow (current US$) of Uruguay in 2006?
Offer a very short reply. 1.40e+06. What is the difference between the Aid flow (current US$) of Moldova in 2005 and the Aid flow (current US$) of Yemen, Rep. in 2006?
Give a very brief answer. -1.84e+06. What is the difference between the Aid flow (current US$) of Samoa in 2005 and the Aid flow (current US$) of Uruguay in 2006?
Provide a succinct answer. 1.02e+07. What is the difference between the Aid flow (current US$) of Samoa in 2005 and the Aid flow (current US$) of Yemen, Rep. in 2006?
Give a very brief answer. 6.97e+06. What is the difference between the Aid flow (current US$) in Uruguay in 2005 and the Aid flow (current US$) in Yemen, Rep. in 2006?
Provide a succinct answer. -3.33e+06. What is the average Aid flow (current US$) in Moldova per year?
Offer a terse response. 4.71e+06. What is the average Aid flow (current US$) in Samoa per year?
Offer a terse response. 1.10e+07. What is the average Aid flow (current US$) in Uruguay per year?
Your response must be concise. 3.80e+06. What is the average Aid flow (current US$) in Yemen, Rep. per year?
Make the answer very short. 1.63e+07. In the year 1999, what is the difference between the Aid flow (current US$) of Moldova and Aid flow (current US$) of Samoa?
Provide a succinct answer. -5.06e+06. In the year 1999, what is the difference between the Aid flow (current US$) in Moldova and Aid flow (current US$) in Uruguay?
Keep it short and to the point. -2.42e+06. In the year 1999, what is the difference between the Aid flow (current US$) of Moldova and Aid flow (current US$) of Yemen, Rep.?
Offer a very short reply. -3.83e+07. In the year 1999, what is the difference between the Aid flow (current US$) of Samoa and Aid flow (current US$) of Uruguay?
Your response must be concise. 2.64e+06. In the year 1999, what is the difference between the Aid flow (current US$) in Samoa and Aid flow (current US$) in Yemen, Rep.?
Keep it short and to the point. -3.33e+07. In the year 1999, what is the difference between the Aid flow (current US$) of Uruguay and Aid flow (current US$) of Yemen, Rep.?
Give a very brief answer. -3.59e+07. In the year 2000, what is the difference between the Aid flow (current US$) in Moldova and Aid flow (current US$) in Samoa?
Provide a succinct answer. -2.68e+06. In the year 2000, what is the difference between the Aid flow (current US$) in Moldova and Aid flow (current US$) in Uruguay?
Keep it short and to the point. -3.18e+06. In the year 2000, what is the difference between the Aid flow (current US$) of Moldova and Aid flow (current US$) of Yemen, Rep.?
Provide a short and direct response. -1.83e+07. In the year 2000, what is the difference between the Aid flow (current US$) in Samoa and Aid flow (current US$) in Uruguay?
Your response must be concise. -5.00e+05. In the year 2000, what is the difference between the Aid flow (current US$) of Samoa and Aid flow (current US$) of Yemen, Rep.?
Your response must be concise. -1.57e+07. In the year 2000, what is the difference between the Aid flow (current US$) of Uruguay and Aid flow (current US$) of Yemen, Rep.?
Your answer should be compact. -1.52e+07. In the year 2001, what is the difference between the Aid flow (current US$) in Moldova and Aid flow (current US$) in Samoa?
Your answer should be very brief. -5.37e+06. In the year 2001, what is the difference between the Aid flow (current US$) of Moldova and Aid flow (current US$) of Uruguay?
Offer a terse response. 2.24e+06. In the year 2001, what is the difference between the Aid flow (current US$) in Moldova and Aid flow (current US$) in Yemen, Rep.?
Provide a succinct answer. 3.25e+06. In the year 2001, what is the difference between the Aid flow (current US$) in Samoa and Aid flow (current US$) in Uruguay?
Your answer should be very brief. 7.61e+06. In the year 2001, what is the difference between the Aid flow (current US$) of Samoa and Aid flow (current US$) of Yemen, Rep.?
Make the answer very short. 8.62e+06. In the year 2001, what is the difference between the Aid flow (current US$) in Uruguay and Aid flow (current US$) in Yemen, Rep.?
Your response must be concise. 1.01e+06. In the year 2002, what is the difference between the Aid flow (current US$) of Moldova and Aid flow (current US$) of Samoa?
Ensure brevity in your answer.  -9.45e+06. In the year 2002, what is the difference between the Aid flow (current US$) of Moldova and Aid flow (current US$) of Uruguay?
Offer a very short reply. 1.83e+06. In the year 2002, what is the difference between the Aid flow (current US$) in Samoa and Aid flow (current US$) in Uruguay?
Your answer should be compact. 1.13e+07. In the year 2002, what is the difference between the Aid flow (current US$) in Samoa and Aid flow (current US$) in Yemen, Rep.?
Provide a short and direct response. 9.38e+06. In the year 2002, what is the difference between the Aid flow (current US$) of Uruguay and Aid flow (current US$) of Yemen, Rep.?
Ensure brevity in your answer.  -1.90e+06. In the year 2003, what is the difference between the Aid flow (current US$) in Moldova and Aid flow (current US$) in Samoa?
Ensure brevity in your answer.  -7.18e+06. In the year 2003, what is the difference between the Aid flow (current US$) of Moldova and Aid flow (current US$) of Uruguay?
Ensure brevity in your answer.  2.19e+06. In the year 2003, what is the difference between the Aid flow (current US$) in Moldova and Aid flow (current US$) in Yemen, Rep.?
Your response must be concise. -2.02e+07. In the year 2003, what is the difference between the Aid flow (current US$) of Samoa and Aid flow (current US$) of Uruguay?
Provide a succinct answer. 9.37e+06. In the year 2003, what is the difference between the Aid flow (current US$) in Samoa and Aid flow (current US$) in Yemen, Rep.?
Your answer should be compact. -1.31e+07. In the year 2003, what is the difference between the Aid flow (current US$) of Uruguay and Aid flow (current US$) of Yemen, Rep.?
Your response must be concise. -2.24e+07. In the year 2004, what is the difference between the Aid flow (current US$) in Moldova and Aid flow (current US$) in Samoa?
Your response must be concise. -1.29e+06. In the year 2004, what is the difference between the Aid flow (current US$) of Moldova and Aid flow (current US$) of Uruguay?
Keep it short and to the point. 1.34e+06. In the year 2004, what is the difference between the Aid flow (current US$) in Moldova and Aid flow (current US$) in Yemen, Rep.?
Offer a terse response. -1.48e+07. In the year 2004, what is the difference between the Aid flow (current US$) of Samoa and Aid flow (current US$) of Uruguay?
Ensure brevity in your answer.  2.63e+06. In the year 2004, what is the difference between the Aid flow (current US$) in Samoa and Aid flow (current US$) in Yemen, Rep.?
Provide a succinct answer. -1.36e+07. In the year 2004, what is the difference between the Aid flow (current US$) in Uruguay and Aid flow (current US$) in Yemen, Rep.?
Make the answer very short. -1.62e+07. In the year 2005, what is the difference between the Aid flow (current US$) of Moldova and Aid flow (current US$) of Samoa?
Your answer should be compact. -8.81e+06. In the year 2005, what is the difference between the Aid flow (current US$) in Moldova and Aid flow (current US$) in Uruguay?
Make the answer very short. 1.49e+06. In the year 2005, what is the difference between the Aid flow (current US$) of Moldova and Aid flow (current US$) of Yemen, Rep.?
Offer a terse response. -4.73e+06. In the year 2005, what is the difference between the Aid flow (current US$) of Samoa and Aid flow (current US$) of Uruguay?
Provide a succinct answer. 1.03e+07. In the year 2005, what is the difference between the Aid flow (current US$) in Samoa and Aid flow (current US$) in Yemen, Rep.?
Your answer should be compact. 4.08e+06. In the year 2005, what is the difference between the Aid flow (current US$) in Uruguay and Aid flow (current US$) in Yemen, Rep.?
Your answer should be compact. -6.22e+06. In the year 2006, what is the difference between the Aid flow (current US$) of Moldova and Aid flow (current US$) of Samoa?
Your answer should be compact. -1.07e+07. In the year 2006, what is the difference between the Aid flow (current US$) of Moldova and Aid flow (current US$) of Uruguay?
Your response must be concise. 3.80e+06. In the year 2006, what is the difference between the Aid flow (current US$) of Moldova and Aid flow (current US$) of Yemen, Rep.?
Provide a succinct answer. 5.60e+05. In the year 2006, what is the difference between the Aid flow (current US$) in Samoa and Aid flow (current US$) in Uruguay?
Provide a succinct answer. 1.45e+07. In the year 2006, what is the difference between the Aid flow (current US$) of Samoa and Aid flow (current US$) of Yemen, Rep.?
Provide a short and direct response. 1.13e+07. In the year 2006, what is the difference between the Aid flow (current US$) in Uruguay and Aid flow (current US$) in Yemen, Rep.?
Offer a terse response. -3.24e+06. What is the ratio of the Aid flow (current US$) in Moldova in 1999 to that in 2000?
Offer a terse response. 1.34. What is the ratio of the Aid flow (current US$) of Samoa in 1999 to that in 2000?
Offer a very short reply. 1.62. What is the ratio of the Aid flow (current US$) in Uruguay in 1999 to that in 2000?
Ensure brevity in your answer.  1.02. What is the ratio of the Aid flow (current US$) of Yemen, Rep. in 1999 to that in 2000?
Your response must be concise. 2. What is the ratio of the Aid flow (current US$) in Moldova in 1999 to that in 2001?
Provide a succinct answer. 0.43. What is the ratio of the Aid flow (current US$) of Samoa in 1999 to that in 2001?
Your answer should be compact. 0.63. What is the ratio of the Aid flow (current US$) in Uruguay in 1999 to that in 2001?
Keep it short and to the point. 1.01. What is the ratio of the Aid flow (current US$) in Yemen, Rep. in 1999 to that in 2001?
Your response must be concise. 8.54. What is the ratio of the Aid flow (current US$) in Moldova in 1999 to that in 2002?
Ensure brevity in your answer.  0.6. What is the ratio of the Aid flow (current US$) in Samoa in 1999 to that in 2002?
Provide a short and direct response. 0.56. What is the ratio of the Aid flow (current US$) of Uruguay in 1999 to that in 2002?
Provide a succinct answer. 1.46. What is the ratio of the Aid flow (current US$) in Yemen, Rep. in 1999 to that in 2002?
Provide a short and direct response. 7. What is the ratio of the Aid flow (current US$) of Moldova in 1999 to that in 2003?
Give a very brief answer. 0.82. What is the ratio of the Aid flow (current US$) in Samoa in 1999 to that in 2003?
Your answer should be compact. 0.75. What is the ratio of the Aid flow (current US$) in Uruguay in 1999 to that in 2003?
Your answer should be compact. 2.82. What is the ratio of the Aid flow (current US$) of Yemen, Rep. in 1999 to that in 2003?
Your response must be concise. 1.71. What is the ratio of the Aid flow (current US$) of Moldova in 1999 to that in 2004?
Your answer should be very brief. 1.06. What is the ratio of the Aid flow (current US$) of Samoa in 1999 to that in 2004?
Your response must be concise. 1.86. What is the ratio of the Aid flow (current US$) of Uruguay in 1999 to that in 2004?
Your answer should be compact. 2.98. What is the ratio of the Aid flow (current US$) of Yemen, Rep. in 1999 to that in 2004?
Provide a succinct answer. 2.3. What is the ratio of the Aid flow (current US$) of Moldova in 1999 to that in 2005?
Your response must be concise. 0.95. What is the ratio of the Aid flow (current US$) of Samoa in 1999 to that in 2005?
Offer a very short reply. 0.69. What is the ratio of the Aid flow (current US$) of Uruguay in 1999 to that in 2005?
Offer a very short reply. 2.68. What is the ratio of the Aid flow (current US$) in Yemen, Rep. in 1999 to that in 2005?
Offer a terse response. 4.96. What is the ratio of the Aid flow (current US$) of Moldova in 1999 to that in 2006?
Your answer should be very brief. 0.58. What is the ratio of the Aid flow (current US$) in Samoa in 1999 to that in 2006?
Make the answer very short. 0.51. What is the ratio of the Aid flow (current US$) in Uruguay in 1999 to that in 2006?
Your answer should be very brief. 2.57. What is the ratio of the Aid flow (current US$) in Yemen, Rep. in 1999 to that in 2006?
Make the answer very short. 7.54. What is the ratio of the Aid flow (current US$) of Moldova in 2000 to that in 2001?
Offer a very short reply. 0.32. What is the ratio of the Aid flow (current US$) in Samoa in 2000 to that in 2001?
Make the answer very short. 0.39. What is the ratio of the Aid flow (current US$) in Uruguay in 2000 to that in 2001?
Provide a succinct answer. 0.98. What is the ratio of the Aid flow (current US$) in Yemen, Rep. in 2000 to that in 2001?
Provide a short and direct response. 4.28. What is the ratio of the Aid flow (current US$) in Moldova in 2000 to that in 2002?
Your response must be concise. 0.45. What is the ratio of the Aid flow (current US$) in Samoa in 2000 to that in 2002?
Give a very brief answer. 0.35. What is the ratio of the Aid flow (current US$) of Uruguay in 2000 to that in 2002?
Provide a short and direct response. 1.42. What is the ratio of the Aid flow (current US$) in Yemen, Rep. in 2000 to that in 2002?
Give a very brief answer. 3.51. What is the ratio of the Aid flow (current US$) of Moldova in 2000 to that in 2003?
Keep it short and to the point. 0.61. What is the ratio of the Aid flow (current US$) of Samoa in 2000 to that in 2003?
Offer a terse response. 0.46. What is the ratio of the Aid flow (current US$) in Uruguay in 2000 to that in 2003?
Your response must be concise. 2.75. What is the ratio of the Aid flow (current US$) in Yemen, Rep. in 2000 to that in 2003?
Keep it short and to the point. 0.85. What is the ratio of the Aid flow (current US$) in Moldova in 2000 to that in 2004?
Provide a succinct answer. 0.79. What is the ratio of the Aid flow (current US$) in Samoa in 2000 to that in 2004?
Your response must be concise. 1.15. What is the ratio of the Aid flow (current US$) in Uruguay in 2000 to that in 2004?
Offer a terse response. 2.92. What is the ratio of the Aid flow (current US$) in Yemen, Rep. in 2000 to that in 2004?
Provide a succinct answer. 1.15. What is the ratio of the Aid flow (current US$) of Moldova in 2000 to that in 2005?
Provide a short and direct response. 0.71. What is the ratio of the Aid flow (current US$) of Samoa in 2000 to that in 2005?
Your response must be concise. 0.42. What is the ratio of the Aid flow (current US$) of Uruguay in 2000 to that in 2005?
Provide a succinct answer. 2.62. What is the ratio of the Aid flow (current US$) in Yemen, Rep. in 2000 to that in 2005?
Keep it short and to the point. 2.48. What is the ratio of the Aid flow (current US$) in Moldova in 2000 to that in 2006?
Your answer should be very brief. 0.43. What is the ratio of the Aid flow (current US$) in Samoa in 2000 to that in 2006?
Your response must be concise. 0.32. What is the ratio of the Aid flow (current US$) in Uruguay in 2000 to that in 2006?
Make the answer very short. 2.52. What is the ratio of the Aid flow (current US$) of Yemen, Rep. in 2000 to that in 2006?
Provide a succinct answer. 3.78. What is the ratio of the Aid flow (current US$) in Moldova in 2001 to that in 2002?
Ensure brevity in your answer.  1.38. What is the ratio of the Aid flow (current US$) in Samoa in 2001 to that in 2002?
Offer a very short reply. 0.88. What is the ratio of the Aid flow (current US$) in Uruguay in 2001 to that in 2002?
Keep it short and to the point. 1.45. What is the ratio of the Aid flow (current US$) of Yemen, Rep. in 2001 to that in 2002?
Ensure brevity in your answer.  0.82. What is the ratio of the Aid flow (current US$) of Moldova in 2001 to that in 2003?
Your response must be concise. 1.9. What is the ratio of the Aid flow (current US$) in Samoa in 2001 to that in 2003?
Keep it short and to the point. 1.18. What is the ratio of the Aid flow (current US$) of Uruguay in 2001 to that in 2003?
Offer a very short reply. 2.8. What is the ratio of the Aid flow (current US$) of Yemen, Rep. in 2001 to that in 2003?
Provide a short and direct response. 0.2. What is the ratio of the Aid flow (current US$) in Moldova in 2001 to that in 2004?
Make the answer very short. 2.45. What is the ratio of the Aid flow (current US$) in Samoa in 2001 to that in 2004?
Offer a very short reply. 2.93. What is the ratio of the Aid flow (current US$) of Uruguay in 2001 to that in 2004?
Your answer should be very brief. 2.97. What is the ratio of the Aid flow (current US$) of Yemen, Rep. in 2001 to that in 2004?
Make the answer very short. 0.27. What is the ratio of the Aid flow (current US$) in Moldova in 2001 to that in 2005?
Provide a short and direct response. 2.2. What is the ratio of the Aid flow (current US$) of Samoa in 2001 to that in 2005?
Keep it short and to the point. 1.08. What is the ratio of the Aid flow (current US$) in Uruguay in 2001 to that in 2005?
Provide a short and direct response. 2.66. What is the ratio of the Aid flow (current US$) in Yemen, Rep. in 2001 to that in 2005?
Your answer should be very brief. 0.58. What is the ratio of the Aid flow (current US$) of Moldova in 2001 to that in 2006?
Offer a very short reply. 1.33. What is the ratio of the Aid flow (current US$) of Samoa in 2001 to that in 2006?
Offer a terse response. 0.8. What is the ratio of the Aid flow (current US$) of Uruguay in 2001 to that in 2006?
Your response must be concise. 2.56. What is the ratio of the Aid flow (current US$) of Yemen, Rep. in 2001 to that in 2006?
Keep it short and to the point. 0.88. What is the ratio of the Aid flow (current US$) in Moldova in 2002 to that in 2003?
Offer a very short reply. 1.37. What is the ratio of the Aid flow (current US$) of Samoa in 2002 to that in 2003?
Offer a terse response. 1.34. What is the ratio of the Aid flow (current US$) in Uruguay in 2002 to that in 2003?
Keep it short and to the point. 1.93. What is the ratio of the Aid flow (current US$) in Yemen, Rep. in 2002 to that in 2003?
Your response must be concise. 0.24. What is the ratio of the Aid flow (current US$) in Moldova in 2002 to that in 2004?
Ensure brevity in your answer.  1.77. What is the ratio of the Aid flow (current US$) in Samoa in 2002 to that in 2004?
Your response must be concise. 3.32. What is the ratio of the Aid flow (current US$) in Uruguay in 2002 to that in 2004?
Ensure brevity in your answer.  2.05. What is the ratio of the Aid flow (current US$) in Yemen, Rep. in 2002 to that in 2004?
Make the answer very short. 0.33. What is the ratio of the Aid flow (current US$) in Moldova in 2002 to that in 2005?
Your answer should be compact. 1.59. What is the ratio of the Aid flow (current US$) in Samoa in 2002 to that in 2005?
Your answer should be very brief. 1.23. What is the ratio of the Aid flow (current US$) in Uruguay in 2002 to that in 2005?
Your answer should be very brief. 1.84. What is the ratio of the Aid flow (current US$) in Yemen, Rep. in 2002 to that in 2005?
Your answer should be very brief. 0.71. What is the ratio of the Aid flow (current US$) in Moldova in 2002 to that in 2006?
Ensure brevity in your answer.  0.97. What is the ratio of the Aid flow (current US$) of Samoa in 2002 to that in 2006?
Provide a short and direct response. 0.91. What is the ratio of the Aid flow (current US$) in Uruguay in 2002 to that in 2006?
Provide a succinct answer. 1.77. What is the ratio of the Aid flow (current US$) in Yemen, Rep. in 2002 to that in 2006?
Your answer should be compact. 1.08. What is the ratio of the Aid flow (current US$) in Moldova in 2003 to that in 2004?
Make the answer very short. 1.29. What is the ratio of the Aid flow (current US$) of Samoa in 2003 to that in 2004?
Make the answer very short. 2.48. What is the ratio of the Aid flow (current US$) in Uruguay in 2003 to that in 2004?
Keep it short and to the point. 1.06. What is the ratio of the Aid flow (current US$) in Yemen, Rep. in 2003 to that in 2004?
Make the answer very short. 1.35. What is the ratio of the Aid flow (current US$) of Moldova in 2003 to that in 2005?
Give a very brief answer. 1.16. What is the ratio of the Aid flow (current US$) in Samoa in 2003 to that in 2005?
Your answer should be compact. 0.92. What is the ratio of the Aid flow (current US$) of Uruguay in 2003 to that in 2005?
Your response must be concise. 0.95. What is the ratio of the Aid flow (current US$) in Yemen, Rep. in 2003 to that in 2005?
Provide a short and direct response. 2.91. What is the ratio of the Aid flow (current US$) in Moldova in 2003 to that in 2006?
Your answer should be very brief. 0.7. What is the ratio of the Aid flow (current US$) of Samoa in 2003 to that in 2006?
Your answer should be compact. 0.68. What is the ratio of the Aid flow (current US$) in Uruguay in 2003 to that in 2006?
Provide a short and direct response. 0.91. What is the ratio of the Aid flow (current US$) of Yemen, Rep. in 2003 to that in 2006?
Make the answer very short. 4.42. What is the ratio of the Aid flow (current US$) of Moldova in 2004 to that in 2005?
Provide a short and direct response. 0.9. What is the ratio of the Aid flow (current US$) of Samoa in 2004 to that in 2005?
Offer a terse response. 0.37. What is the ratio of the Aid flow (current US$) of Uruguay in 2004 to that in 2005?
Provide a succinct answer. 0.9. What is the ratio of the Aid flow (current US$) in Yemen, Rep. in 2004 to that in 2005?
Make the answer very short. 2.15. What is the ratio of the Aid flow (current US$) of Moldova in 2004 to that in 2006?
Ensure brevity in your answer.  0.55. What is the ratio of the Aid flow (current US$) in Samoa in 2004 to that in 2006?
Provide a short and direct response. 0.27. What is the ratio of the Aid flow (current US$) of Uruguay in 2004 to that in 2006?
Offer a very short reply. 0.86. What is the ratio of the Aid flow (current US$) of Yemen, Rep. in 2004 to that in 2006?
Your response must be concise. 3.28. What is the ratio of the Aid flow (current US$) of Moldova in 2005 to that in 2006?
Ensure brevity in your answer.  0.61. What is the ratio of the Aid flow (current US$) in Samoa in 2005 to that in 2006?
Offer a very short reply. 0.74. What is the ratio of the Aid flow (current US$) in Uruguay in 2005 to that in 2006?
Provide a succinct answer. 0.96. What is the ratio of the Aid flow (current US$) in Yemen, Rep. in 2005 to that in 2006?
Your answer should be compact. 1.52. What is the difference between the highest and the second highest Aid flow (current US$) in Moldova?
Offer a very short reply. 2.04e+06. What is the difference between the highest and the second highest Aid flow (current US$) in Samoa?
Make the answer very short. 1.45e+06. What is the difference between the highest and the second highest Aid flow (current US$) of Yemen, Rep.?
Provide a succinct answer. 1.73e+07. What is the difference between the highest and the lowest Aid flow (current US$) in Moldova?
Provide a short and direct response. 5.52e+06. What is the difference between the highest and the lowest Aid flow (current US$) of Samoa?
Your answer should be very brief. 1.22e+07. What is the difference between the highest and the lowest Aid flow (current US$) of Uruguay?
Provide a succinct answer. 3.95e+06. What is the difference between the highest and the lowest Aid flow (current US$) in Yemen, Rep.?
Keep it short and to the point. 3.69e+07. 